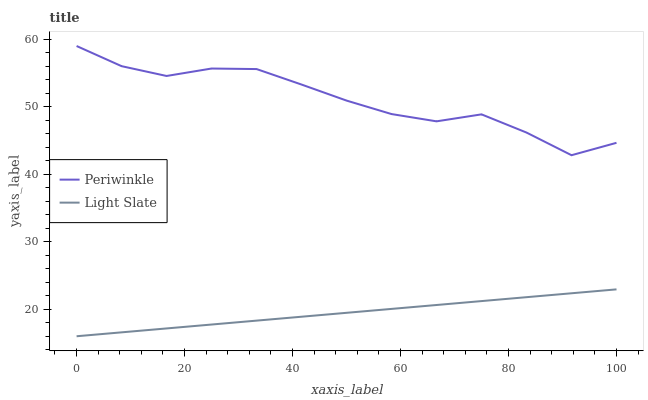Does Periwinkle have the minimum area under the curve?
Answer yes or no. No. Is Periwinkle the smoothest?
Answer yes or no. No. Does Periwinkle have the lowest value?
Answer yes or no. No. Is Light Slate less than Periwinkle?
Answer yes or no. Yes. Is Periwinkle greater than Light Slate?
Answer yes or no. Yes. Does Light Slate intersect Periwinkle?
Answer yes or no. No. 